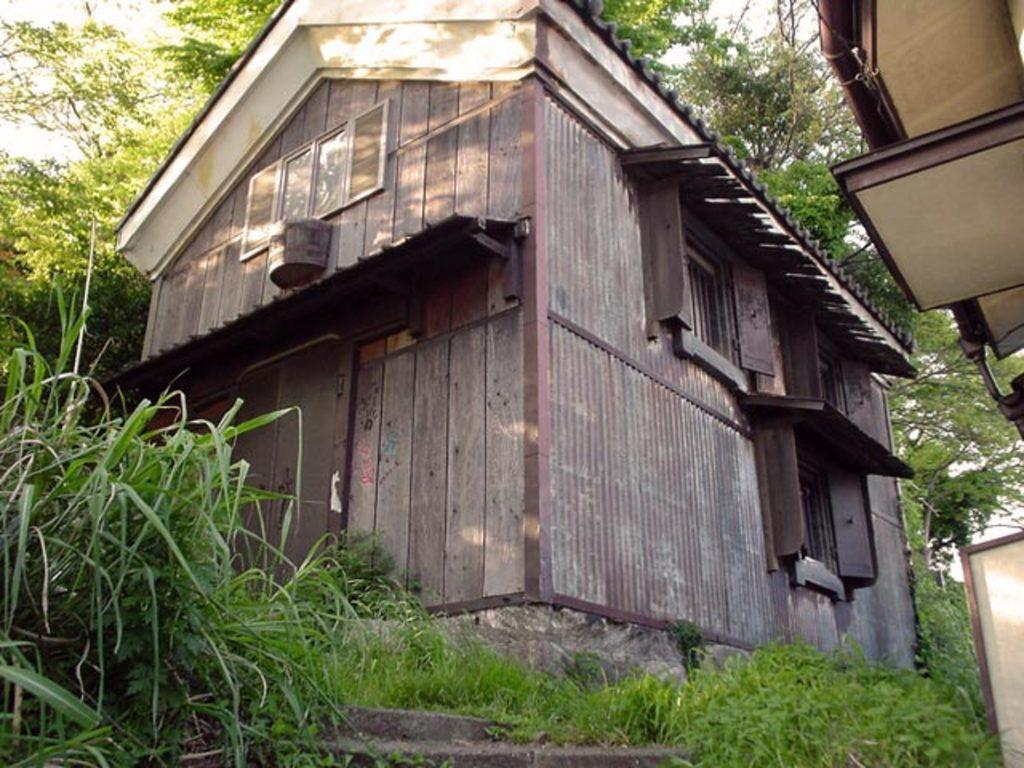What type of structure is visible in the image? There is a building in the image. What type of vegetation is at the bottom of the image? There is grass at the bottom of the image. What can be seen on the left side of the image? There is a plant on the left side of the image. What is visible in the background of the image? There is a tree in the background of the image. How many trucks are parked near the building in the image? There are no trucks visible in the image; it only features a building, grass, a plant, and a tree. Can you see a quill being used to write on the plant in the image? There is no quill or writing activity present in the image. 